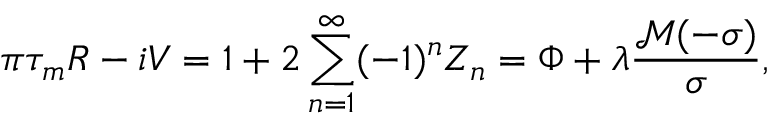<formula> <loc_0><loc_0><loc_500><loc_500>\pi \tau _ { m } R - i V = 1 + 2 \sum _ { n = 1 } ^ { \infty } ( - 1 ) ^ { n } Z _ { n } = \Phi + \lambda \frac { \mathcal { M } ( - \sigma ) } \sigma ,</formula> 